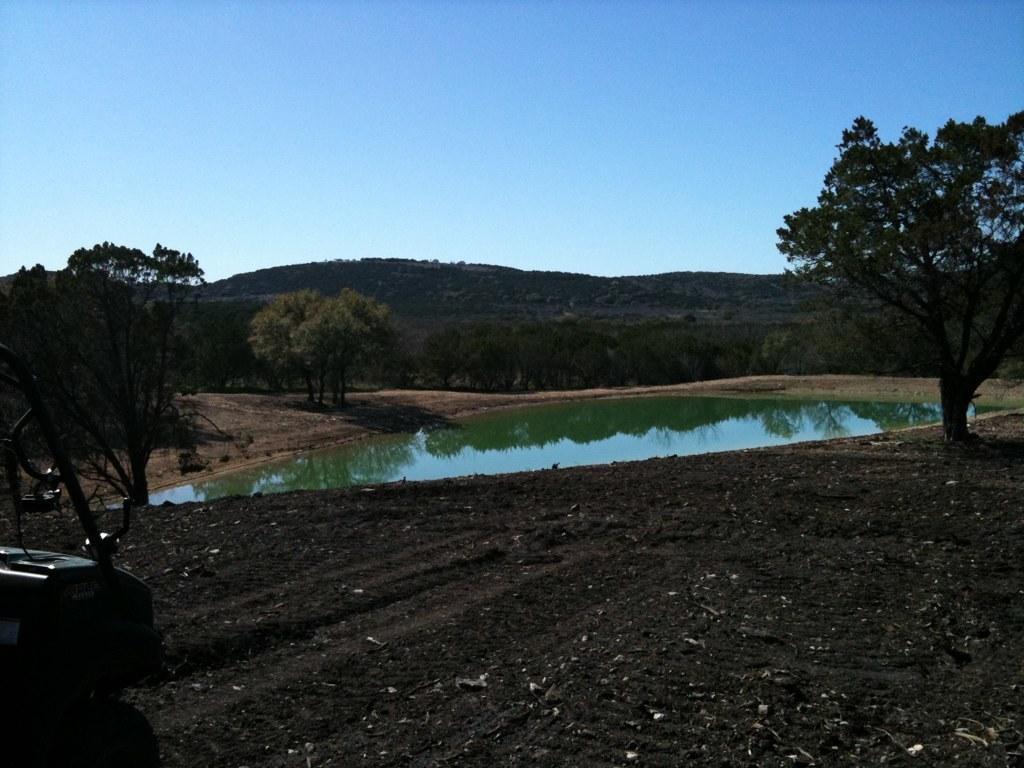Describe this image in one or two sentences. In this image we can see a vehicle on the ground, there is a pond, around the pound there are some trees, in the background we can see mountains and a sky. 